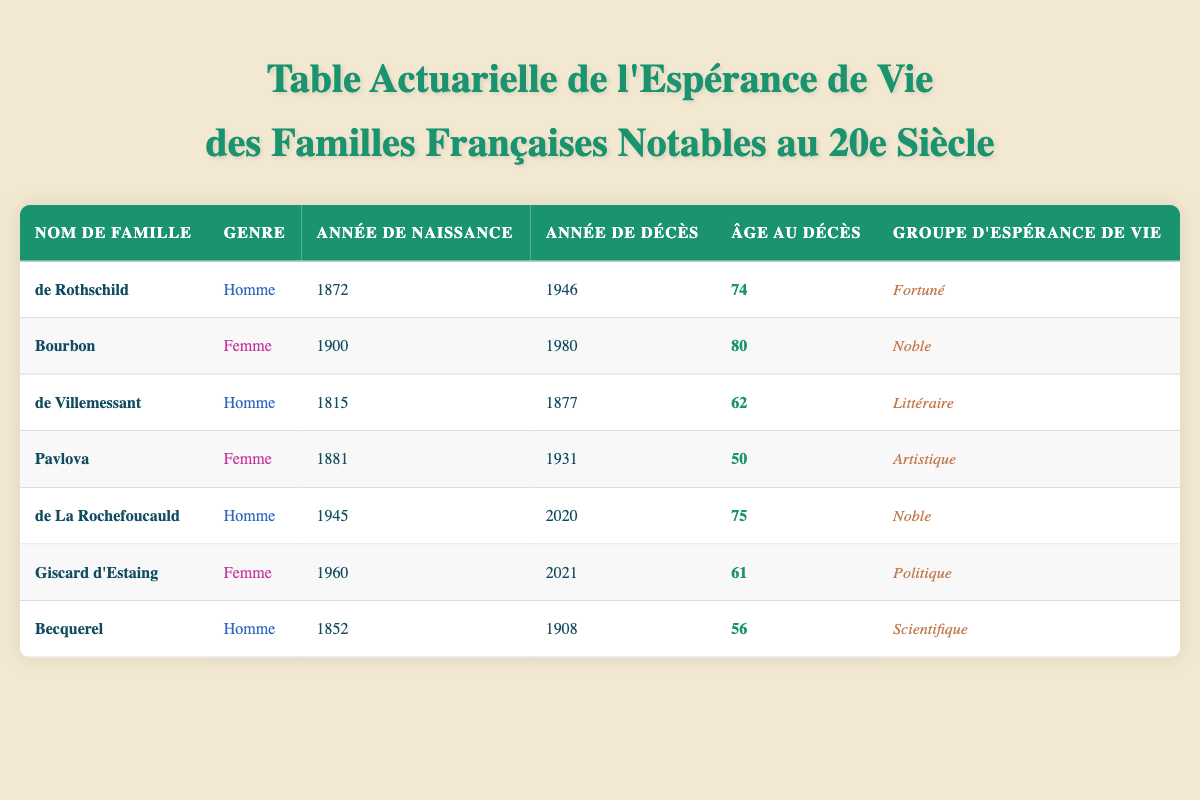Quel est l'âge au décès de la famille Bourbon ? En consultant la table, je vois que la famille Bourbon a vécu jusqu'à 1980 et est née en 1900. L'âge au décès est clairement indiqué comme étant 80.
Answer: 80 Quelle famille a la plus grande espérance de vie ? En examinant les âges au décès de chaque famille dans la table, je note que les familles de Rothschild et Bourbon ont respectivement 74 et 80 ans au décès. La famille Bourbon a donc l'âge le plus élevé.
Answer: Bourbon Combien de familles ont atteint un âge supérieur à 70 ans ? Dans la table, je compte les âges au décès : Rothschild (74), Bourbon (80), de La Rochefoucauld (75), et Becquerel (56). Trois familles (Rothschild, Bourbon, et de La Rochefoucauld) ont dépassé 70 ans.
Answer: 3 Quelle est l'espérance de vie moyenne des hommes dans la liste ? Je prends les âges au décès des hommes : de Rothschild (74), de Villemessant (62), de La Rochefoucauld (75), et Becquerel (56). Leur somme est 74 + 62 + 75 + 56 = 267, et comme il y a 4 hommes, l'espérance de vie moyenne est 267/4 = 66,75.
Answer: 66,75 Y a-t-il une différence d'âge au décès entre les familles artistiques et littéraires ? Pour la famille Pavlova (artistique), l'âge au décès est 50, tandis que pour de Villemessant (littéraire), c'est 62. La différence est de 62 - 50 = 12 ans, donc les littéraires vivent en moyenne plus longtemps.
Answer: Oui, 12 ans Qui est la famille avec l'âge au décès le plus bas et quel est cet âge ? En regardant la table, je repère que la famille avec l'âge au décès le plus bas est Pavlova, qui est décédée à l'âge de 50 ans.
Answer: Pavlova, 50 Est-ce que la famille Giscard d'Estaing a vécu plus longtemps que la famille de La Rochefoucauld ? En consultant la table, Giscard d'Estaing est décédée à 61 ans et de La Rochefoucauld à 75 ans. Évidemment, de La Rochefoucauld a eu une vie plus longue.
Answer: Non Combien d'années en moyenne ont vécu les membres de la catégorie "Noble" ? Les âges au décès dans la catégorie "Noble" incluent Bourbon (80) et de La Rochefoucauld (75). Leur somme est 80 + 75 = 155, et avec deux familles, la moyenne est 155/2 = 77,5.
Answer: 77,5 